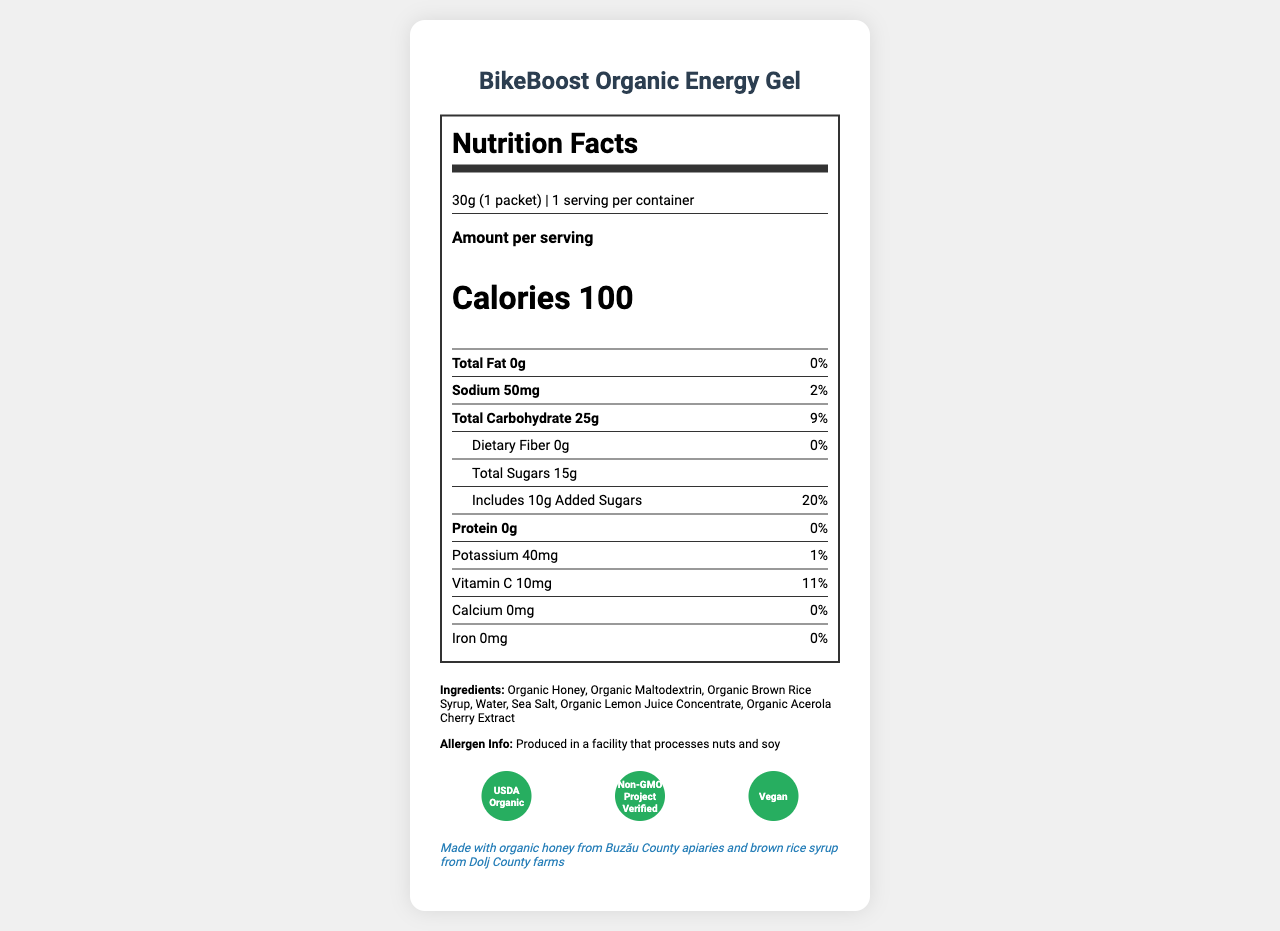what is the serving size? The document lists the serving size as "30g (1 packet)".
Answer: 30g (1 packet) how many calories are in one serving? The document shows that one serving contains 100 calories.
Answer: 100 calories what is the total carbohydrate amount per serving? The document states that one serving contains 25g of total carbohydrates.
Answer: 25g are there any added sugars in the gel? The document shows that there are 10g of added sugars per serving.
Answer: Yes where is the manufacturer of this gel located? The document lists the manufacturer's address as "Str. Bicaz 7, Sector 2, Bucharest, Romania".
Answer: Str. Bicaz 7, Sector 2, Bucharest, Romania what vitamins are included and in what amount? A. Vitamin A - 5mg B. Vitamin B - 2mg C. Vitamin C - 10mg D. Vitamin D - 15mg The document lists 10mg of Vitamin C as part of the nutritional information.
Answer: C. Vitamin C - 10mg how much sodium is in one serving? A. 25mg B. 50mg C. 75mg D. 100mg The document indicates that one serving contains 50mg of sodium.
Answer: B. 50mg is the product organic? The document includes certifications, one of which is "USDA Organic".
Answer: Yes are there any allergens in this gel? The document mentions allergen information, specifically that it is produced in a facility that processes nuts and soy.
Answer: Produced in a facility that processes nuts and soy what are the main ingredients? The document lists the ingredients in a section that includes Organic Honey, Organic Maltodextrin, Organic Brown Rice Syrup, Water, Sea Salt, Organic Lemon Juice Concentrate, and Organic Acerola Cherry Extract.
Answer: Organic Honey, Organic Maltodextrin, Organic Brown Rice Syrup, Water, Sea Salt, Organic Lemon Juice Concentrate, Organic Acerola Cherry Extract what should be done after opening the packet? The document states that the gel should be consumed within 24 hours of opening.
Answer: Consume within 24 hours who is the manufacturer of the gel? The document states that the manufacturer is NutriSport Romania.
Answer: NutriSport Romania is this product suitable for vegans? The document confirms that the product is vegan as indicated by the "Vegan" certification.
Answer: Yes what is the local sourcing information for this product? The document provides local sourcing information, stating it is made with organic honey from Buzău County apiaries and brown rice syrup from Dolj County farms.
Answer: Made with organic honey from Buzău County apiaries and brown rice syrup from Dolj County farms how much fiber does one serving contain? The document states that the dietary fiber amount per serving is 0g.
Answer: 0g how many packets are recommended per hour during intense cycling activities? The document recommends consuming 1-2 packets per hour during intense cycling activities.
Answer: 1-2 packets can I determine the price of the gel packet from the document information? The document does not provide any information regarding the price of the gel packet.
Answer: Cannot be determined describe the main idea of the document. The document provides all necessary information about the BikeBoost Organic Energy Gel, including its nutritional content, ingredients, certifications, and usage instructions, giving insight into the product's quality and benefits for athletes.
Answer: The document is a Nutrition Facts Label for BikeBoost Organic Energy Gel, detailing serving size, nutritional content, ingredients, allergen information, certifications, local sourcing, usage instructions, and manufacturer details. 